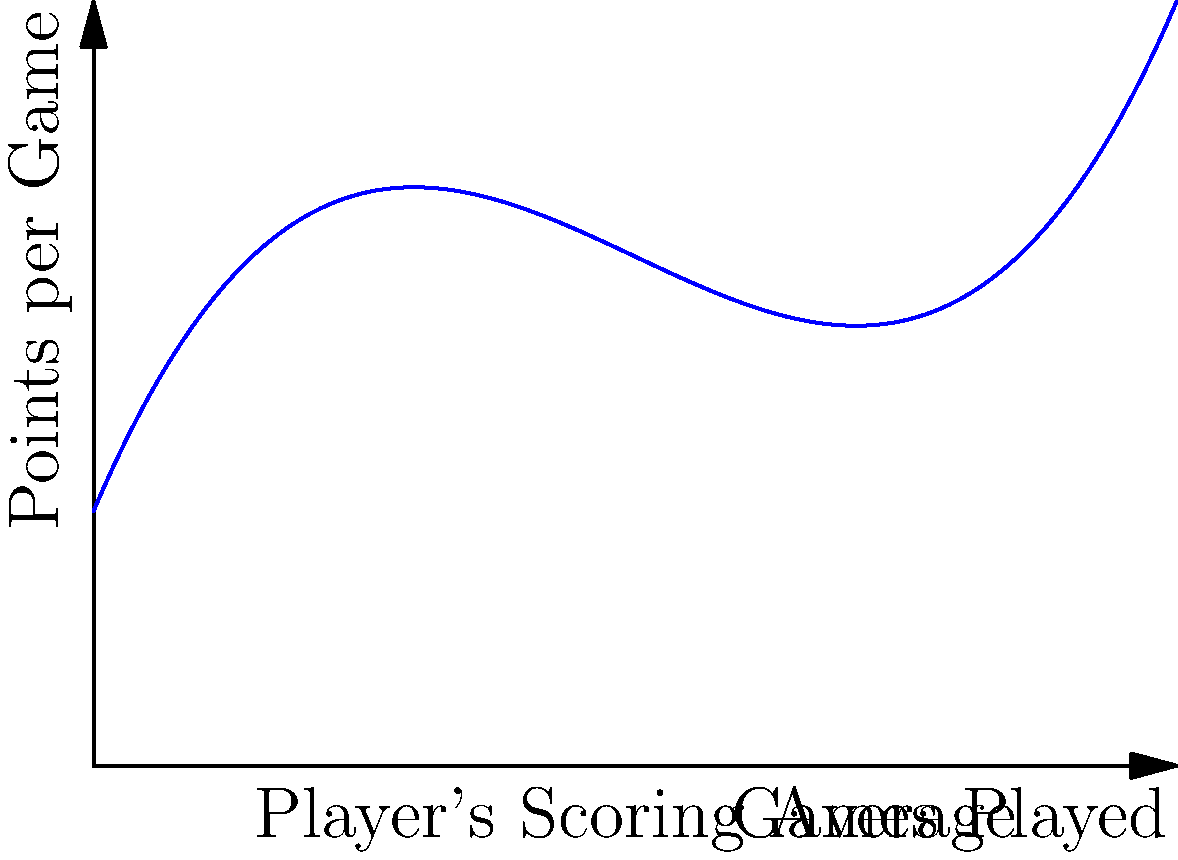As a radio producer researching sports statistics, you're analyzing a basketball player's scoring performance. The player's average points per game (y) after x games played is modeled by the function $y = 0.02x^3 - 0.6x^2 + 5x + 10$. What is the instantaneous rate of change in the player's scoring average after 10 games? To find the instantaneous rate of change in the player's scoring average after 10 games, we need to calculate the derivative of the function at x = 10.

Step 1: Find the derivative of the function.
$y = 0.02x^3 - 0.6x^2 + 5x + 10$
$\frac{dy}{dx} = 0.06x^2 - 1.2x + 5$

Step 2: Substitute x = 10 into the derivative function.
$\frac{dy}{dx}|_{x=10} = 0.06(10)^2 - 1.2(10) + 5$

Step 3: Calculate the result.
$\frac{dy}{dx}|_{x=10} = 0.06(100) - 12 + 5$
$\frac{dy}{dx}|_{x=10} = 6 - 12 + 5 = -1$

The negative value indicates that the player's scoring average is decreasing at this point.
Answer: $-1$ points per game 